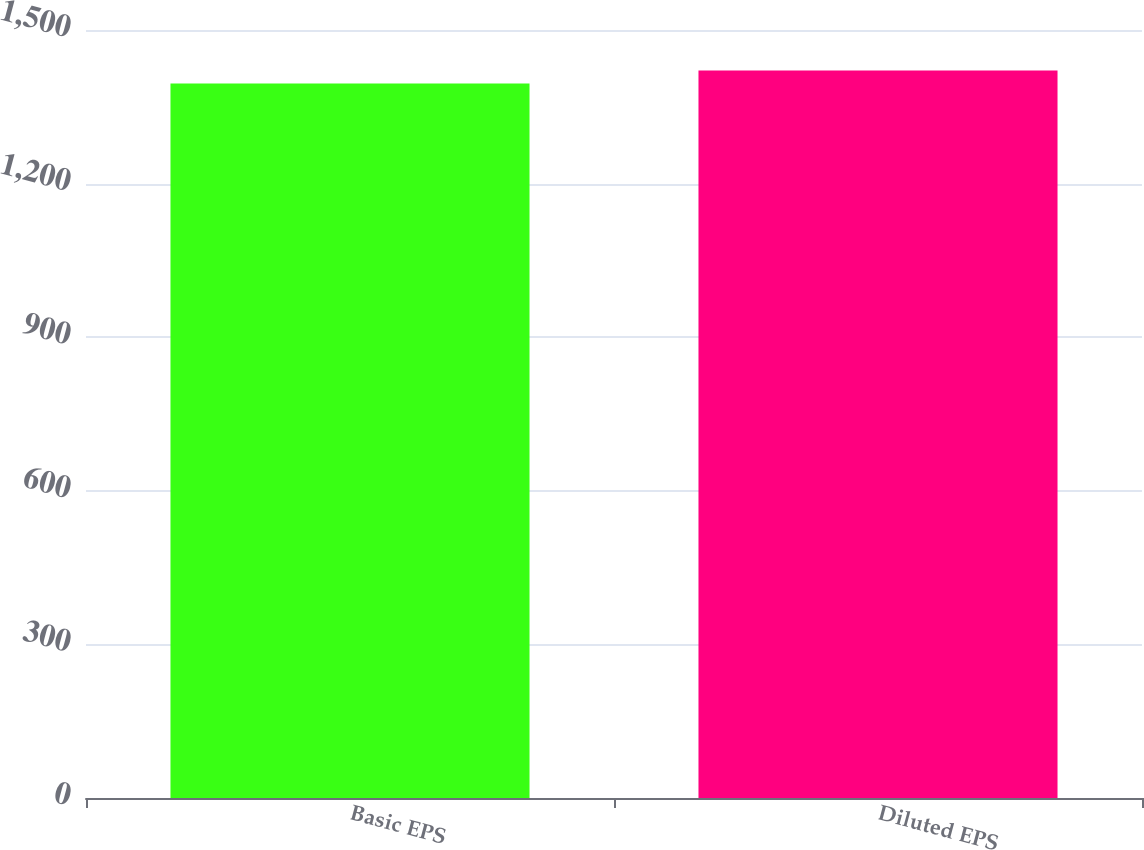<chart> <loc_0><loc_0><loc_500><loc_500><bar_chart><fcel>Basic EPS<fcel>Diluted EPS<nl><fcel>1395.6<fcel>1421.1<nl></chart> 